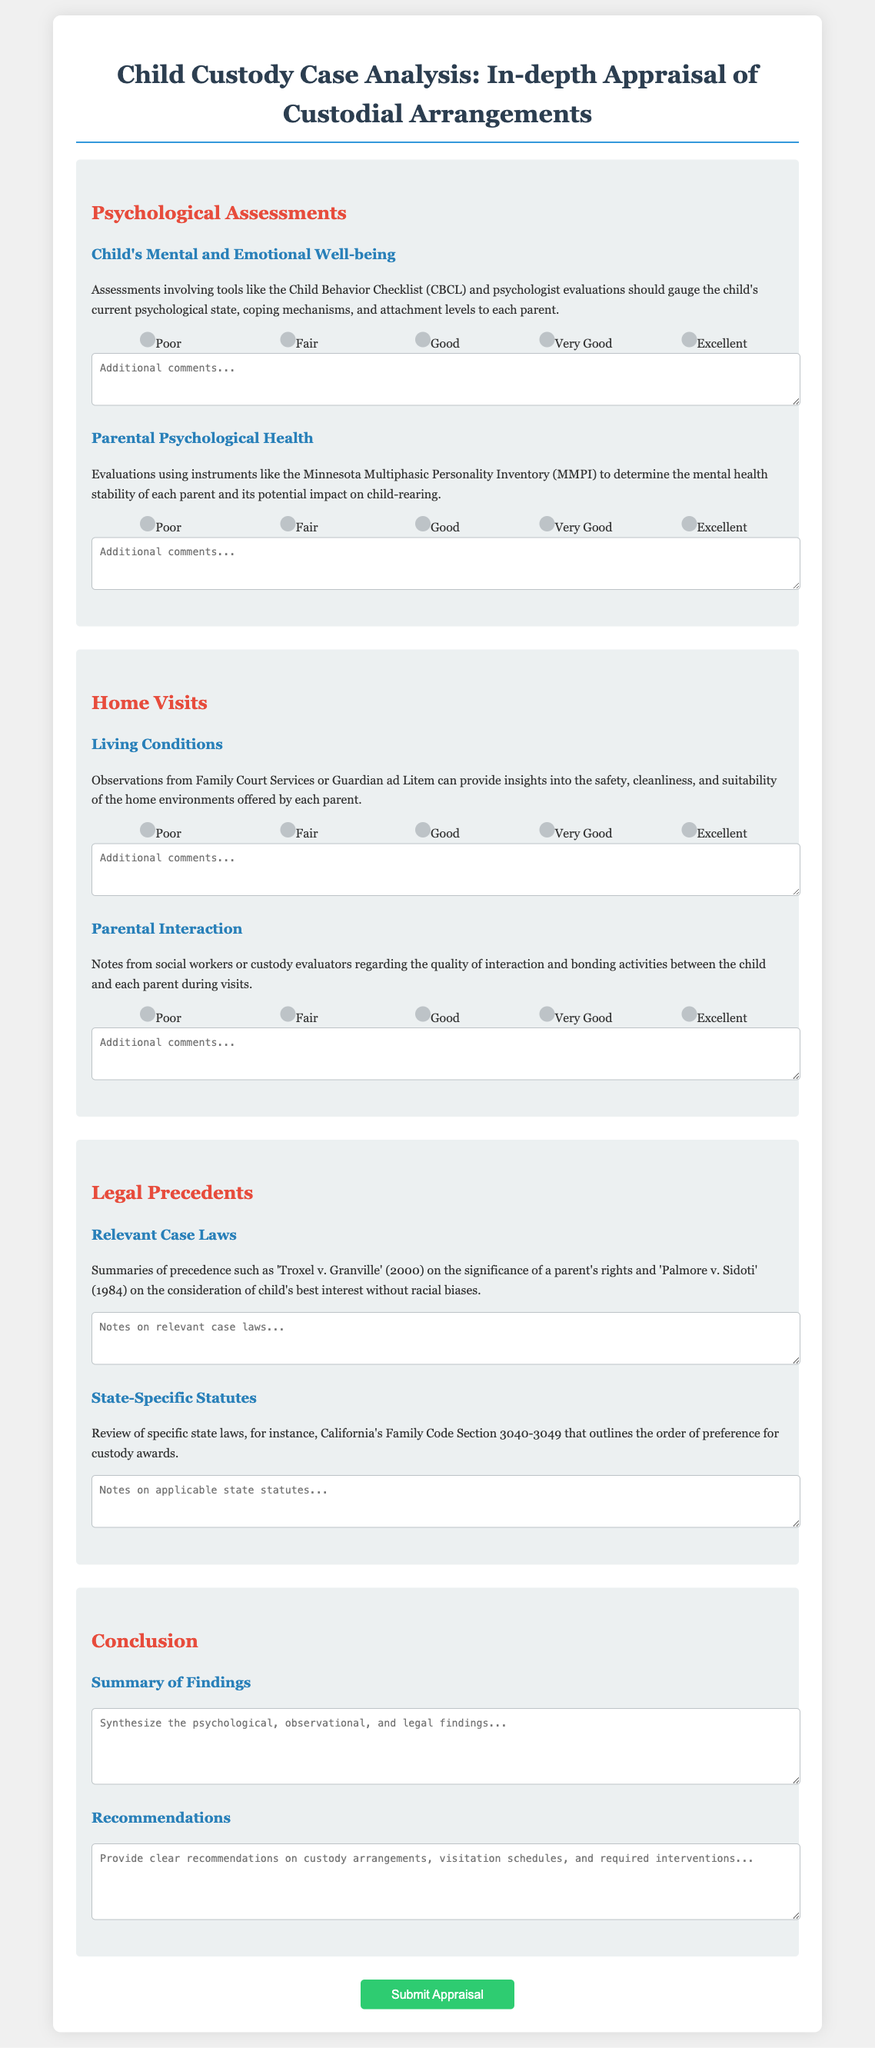What is the title of the document? The title of the document is presented as the main heading at the top.
Answer: Child Custody Case Analysis: In-depth Appraisal of Custodial Arrangements What psychological assessment tool is mentioned for evaluating the child's mental state? The document specifies a particular assessment tool for evaluating the child's psychological state.
Answer: Child Behavior Checklist (CBCL) Which section outlines parental interaction observations? There is a specific section that discusses the quality of interaction and bonding activities.
Answer: Home Visits What is the rating associated with ‘Very Good’ for Child's Mental and Emotional Well-being? The rating scale ranges from 1 to 5, with corresponding labels for each level of wellbeing.
Answer: 4 What relevant case law is noted regarding a parent's rights? This question seeks a specific case that highlights a significant legal precedent for custodial arrangements.
Answer: Troxel v. Granville How many content items are there under the Home Visits section? The inquiry focuses on the number of items listed for evaluation in that particular section.
Answer: 2 What is the purpose of the conclusions drawn in the document? The document aims to synthesize findings and provide recommendations based on previous sections.
Answer: Summary of Findings What does the document suggest should be included in the recommendations? This question asks for the nature of suggestions proposed related to custody arrangements.
Answer: Custody arrangements, visitation schedules, and required interventions 